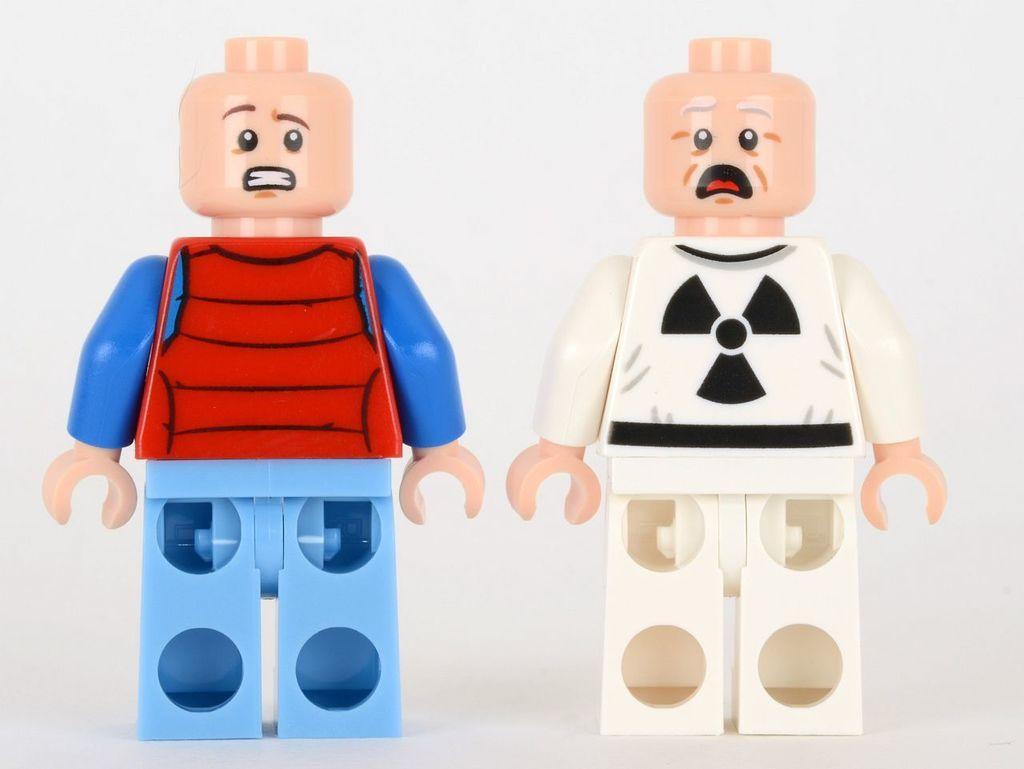Describe this image in one or two sentences. In this image I can see two toys. The background is in white color. 